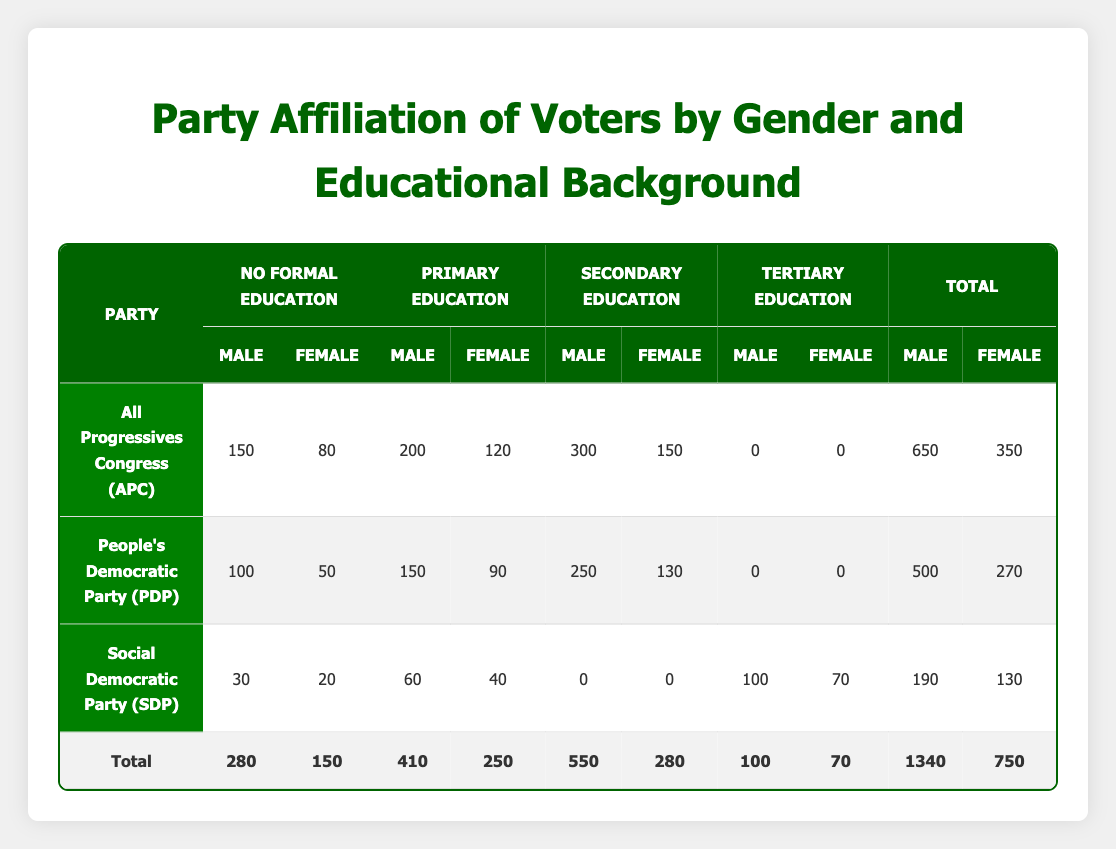What is the total number of male voters affiliated with the All Progressives Congress (APC)? To find the total number of male voters affiliated with APC, we sum the counts from the 'Male' column for all educational backgrounds under APC. That is 150 (No Formal Education) + 200 (Primary Education) + 300 (Secondary Education) + 0 (Tertiary Education) = 650.
Answer: 650 What is the total count of female voters for the People's Democratic Party (PDP)? We need to sum the counts from the 'Female' column for all educational backgrounds under PDP. That would be 50 (No Formal Education) + 90 (Primary Education) + 130 (Secondary Education) + 0 (Tertiary Education) = 270.
Answer: 270 How many male voters do not have formal education and support the Social Democratic Party (SDP)? The count for male voters with No Formal Education supporting SDP is listed as 30 in the table.
Answer: 30 Which party has the highest number of total voters across all educational backgrounds? To determine this, we sum the total counts for each party. For APC: 650 (Male) + 350 (Female) = 1000; PDP: 500 (Male) + 270 (Female) = 770; SDP: 190 (Male) + 130 (Female) = 320. The highest total is 1000 for APC.
Answer: APC Is it true that there are more male voters than female voters in the category of Secondary Education for the People's Democratic Party (PDP)? Under Secondary Education for PDP, the count is 250 male voters and 130 female voters. Since 250 is greater than 130, the statement is true.
Answer: Yes What is the average number of female voters affiliated with the All Progressives Congress (APC)? Collecting the counts of female voters under APC: 80 (No Formal Education) + 120 (Primary Education) + 150 (Secondary Education) + 0 (Tertiary Education) = 350. The average is calculated by dividing total female voters by the number of educational categories considered, which is 350/3 = approximately 116.67.
Answer: Approximately 116.67 What is the difference in the number of male voters between the APC and the PDP who have Primary Education? The number of male voters with Primary Education is 200 for APC and 150 for PDP. The difference is calculated as 200 - 150 = 50.
Answer: 50 Which party has the least number of total voters, and what is that total? We previously calculated the total counts: APC has 1000, PDP has 770, and SDP has 320. SDP has the least at 320 total voters.
Answer: SDP, 320 What percentage of the total voters are female voters across all parties? First, we need the total number of female voters: 350 (APC) + 270 (PDP) + 130 (SDP) = 750. The grand total of voters is 1340. The percentage is (750/1340) * 100 = approximately 56.04%.
Answer: Approximately 56.04% 